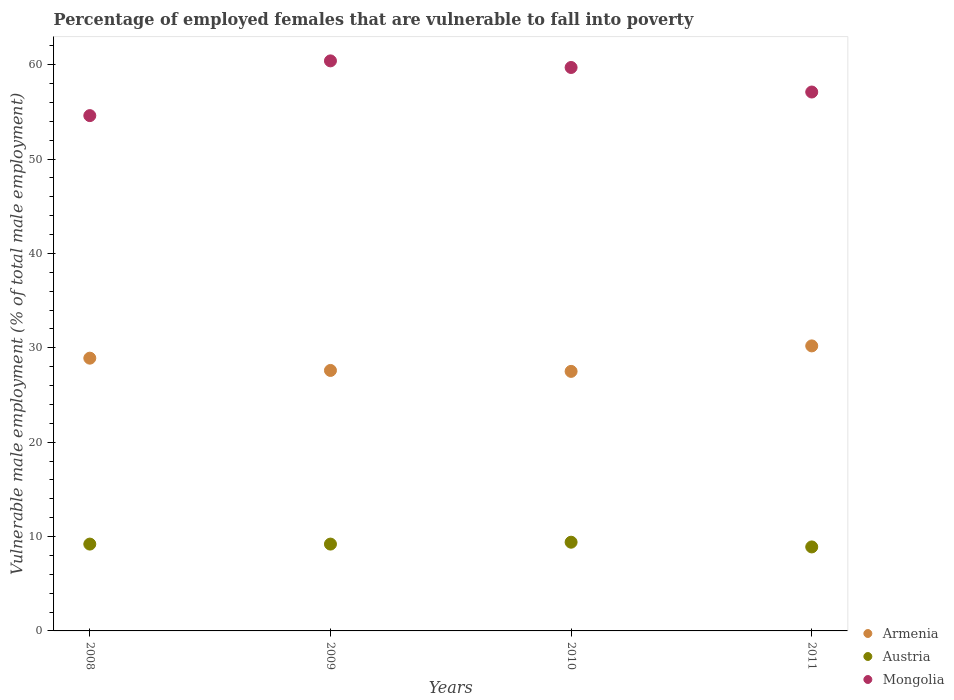Is the number of dotlines equal to the number of legend labels?
Provide a short and direct response. Yes. What is the percentage of employed females who are vulnerable to fall into poverty in Austria in 2011?
Make the answer very short. 8.9. Across all years, what is the maximum percentage of employed females who are vulnerable to fall into poverty in Mongolia?
Make the answer very short. 60.4. In which year was the percentage of employed females who are vulnerable to fall into poverty in Mongolia maximum?
Your response must be concise. 2009. What is the total percentage of employed females who are vulnerable to fall into poverty in Austria in the graph?
Offer a terse response. 36.7. What is the difference between the percentage of employed females who are vulnerable to fall into poverty in Armenia in 2009 and that in 2010?
Keep it short and to the point. 0.1. What is the difference between the percentage of employed females who are vulnerable to fall into poverty in Austria in 2011 and the percentage of employed females who are vulnerable to fall into poverty in Armenia in 2008?
Provide a short and direct response. -20. What is the average percentage of employed females who are vulnerable to fall into poverty in Armenia per year?
Your response must be concise. 28.55. In the year 2008, what is the difference between the percentage of employed females who are vulnerable to fall into poverty in Austria and percentage of employed females who are vulnerable to fall into poverty in Mongolia?
Provide a short and direct response. -45.4. In how many years, is the percentage of employed females who are vulnerable to fall into poverty in Austria greater than 44 %?
Make the answer very short. 0. What is the ratio of the percentage of employed females who are vulnerable to fall into poverty in Armenia in 2008 to that in 2011?
Ensure brevity in your answer.  0.96. Is the percentage of employed females who are vulnerable to fall into poverty in Mongolia in 2008 less than that in 2011?
Offer a very short reply. Yes. Is the difference between the percentage of employed females who are vulnerable to fall into poverty in Austria in 2009 and 2011 greater than the difference between the percentage of employed females who are vulnerable to fall into poverty in Mongolia in 2009 and 2011?
Give a very brief answer. No. What is the difference between the highest and the second highest percentage of employed females who are vulnerable to fall into poverty in Mongolia?
Your response must be concise. 0.7. In how many years, is the percentage of employed females who are vulnerable to fall into poverty in Armenia greater than the average percentage of employed females who are vulnerable to fall into poverty in Armenia taken over all years?
Make the answer very short. 2. Is the percentage of employed females who are vulnerable to fall into poverty in Mongolia strictly greater than the percentage of employed females who are vulnerable to fall into poverty in Austria over the years?
Provide a succinct answer. Yes. Does the graph contain grids?
Offer a terse response. No. How many legend labels are there?
Make the answer very short. 3. What is the title of the graph?
Keep it short and to the point. Percentage of employed females that are vulnerable to fall into poverty. What is the label or title of the X-axis?
Offer a terse response. Years. What is the label or title of the Y-axis?
Your response must be concise. Vulnerable male employment (% of total male employment). What is the Vulnerable male employment (% of total male employment) in Armenia in 2008?
Offer a very short reply. 28.9. What is the Vulnerable male employment (% of total male employment) of Austria in 2008?
Keep it short and to the point. 9.2. What is the Vulnerable male employment (% of total male employment) of Mongolia in 2008?
Offer a terse response. 54.6. What is the Vulnerable male employment (% of total male employment) in Armenia in 2009?
Offer a very short reply. 27.6. What is the Vulnerable male employment (% of total male employment) in Austria in 2009?
Your answer should be very brief. 9.2. What is the Vulnerable male employment (% of total male employment) in Mongolia in 2009?
Provide a short and direct response. 60.4. What is the Vulnerable male employment (% of total male employment) in Austria in 2010?
Your response must be concise. 9.4. What is the Vulnerable male employment (% of total male employment) of Mongolia in 2010?
Your answer should be very brief. 59.7. What is the Vulnerable male employment (% of total male employment) of Armenia in 2011?
Your answer should be very brief. 30.2. What is the Vulnerable male employment (% of total male employment) in Austria in 2011?
Offer a very short reply. 8.9. What is the Vulnerable male employment (% of total male employment) of Mongolia in 2011?
Provide a short and direct response. 57.1. Across all years, what is the maximum Vulnerable male employment (% of total male employment) in Armenia?
Provide a succinct answer. 30.2. Across all years, what is the maximum Vulnerable male employment (% of total male employment) of Austria?
Offer a very short reply. 9.4. Across all years, what is the maximum Vulnerable male employment (% of total male employment) of Mongolia?
Provide a short and direct response. 60.4. Across all years, what is the minimum Vulnerable male employment (% of total male employment) of Austria?
Provide a succinct answer. 8.9. Across all years, what is the minimum Vulnerable male employment (% of total male employment) in Mongolia?
Your answer should be very brief. 54.6. What is the total Vulnerable male employment (% of total male employment) of Armenia in the graph?
Your answer should be compact. 114.2. What is the total Vulnerable male employment (% of total male employment) of Austria in the graph?
Offer a very short reply. 36.7. What is the total Vulnerable male employment (% of total male employment) of Mongolia in the graph?
Give a very brief answer. 231.8. What is the difference between the Vulnerable male employment (% of total male employment) of Armenia in 2008 and that in 2009?
Keep it short and to the point. 1.3. What is the difference between the Vulnerable male employment (% of total male employment) of Armenia in 2008 and that in 2010?
Offer a very short reply. 1.4. What is the difference between the Vulnerable male employment (% of total male employment) in Mongolia in 2008 and that in 2010?
Give a very brief answer. -5.1. What is the difference between the Vulnerable male employment (% of total male employment) of Armenia in 2009 and that in 2010?
Make the answer very short. 0.1. What is the difference between the Vulnerable male employment (% of total male employment) in Armenia in 2009 and that in 2011?
Your answer should be very brief. -2.6. What is the difference between the Vulnerable male employment (% of total male employment) of Mongolia in 2009 and that in 2011?
Make the answer very short. 3.3. What is the difference between the Vulnerable male employment (% of total male employment) of Armenia in 2010 and that in 2011?
Provide a succinct answer. -2.7. What is the difference between the Vulnerable male employment (% of total male employment) of Mongolia in 2010 and that in 2011?
Provide a succinct answer. 2.6. What is the difference between the Vulnerable male employment (% of total male employment) in Armenia in 2008 and the Vulnerable male employment (% of total male employment) in Austria in 2009?
Make the answer very short. 19.7. What is the difference between the Vulnerable male employment (% of total male employment) in Armenia in 2008 and the Vulnerable male employment (% of total male employment) in Mongolia in 2009?
Your answer should be compact. -31.5. What is the difference between the Vulnerable male employment (% of total male employment) of Austria in 2008 and the Vulnerable male employment (% of total male employment) of Mongolia in 2009?
Your answer should be very brief. -51.2. What is the difference between the Vulnerable male employment (% of total male employment) in Armenia in 2008 and the Vulnerable male employment (% of total male employment) in Mongolia in 2010?
Ensure brevity in your answer.  -30.8. What is the difference between the Vulnerable male employment (% of total male employment) in Austria in 2008 and the Vulnerable male employment (% of total male employment) in Mongolia in 2010?
Keep it short and to the point. -50.5. What is the difference between the Vulnerable male employment (% of total male employment) of Armenia in 2008 and the Vulnerable male employment (% of total male employment) of Mongolia in 2011?
Offer a very short reply. -28.2. What is the difference between the Vulnerable male employment (% of total male employment) of Austria in 2008 and the Vulnerable male employment (% of total male employment) of Mongolia in 2011?
Offer a terse response. -47.9. What is the difference between the Vulnerable male employment (% of total male employment) of Armenia in 2009 and the Vulnerable male employment (% of total male employment) of Austria in 2010?
Your answer should be compact. 18.2. What is the difference between the Vulnerable male employment (% of total male employment) in Armenia in 2009 and the Vulnerable male employment (% of total male employment) in Mongolia in 2010?
Offer a terse response. -32.1. What is the difference between the Vulnerable male employment (% of total male employment) in Austria in 2009 and the Vulnerable male employment (% of total male employment) in Mongolia in 2010?
Offer a very short reply. -50.5. What is the difference between the Vulnerable male employment (% of total male employment) in Armenia in 2009 and the Vulnerable male employment (% of total male employment) in Mongolia in 2011?
Ensure brevity in your answer.  -29.5. What is the difference between the Vulnerable male employment (% of total male employment) in Austria in 2009 and the Vulnerable male employment (% of total male employment) in Mongolia in 2011?
Your response must be concise. -47.9. What is the difference between the Vulnerable male employment (% of total male employment) of Armenia in 2010 and the Vulnerable male employment (% of total male employment) of Austria in 2011?
Keep it short and to the point. 18.6. What is the difference between the Vulnerable male employment (% of total male employment) in Armenia in 2010 and the Vulnerable male employment (% of total male employment) in Mongolia in 2011?
Give a very brief answer. -29.6. What is the difference between the Vulnerable male employment (% of total male employment) of Austria in 2010 and the Vulnerable male employment (% of total male employment) of Mongolia in 2011?
Offer a terse response. -47.7. What is the average Vulnerable male employment (% of total male employment) in Armenia per year?
Provide a succinct answer. 28.55. What is the average Vulnerable male employment (% of total male employment) in Austria per year?
Provide a short and direct response. 9.18. What is the average Vulnerable male employment (% of total male employment) of Mongolia per year?
Your answer should be very brief. 57.95. In the year 2008, what is the difference between the Vulnerable male employment (% of total male employment) of Armenia and Vulnerable male employment (% of total male employment) of Mongolia?
Give a very brief answer. -25.7. In the year 2008, what is the difference between the Vulnerable male employment (% of total male employment) in Austria and Vulnerable male employment (% of total male employment) in Mongolia?
Give a very brief answer. -45.4. In the year 2009, what is the difference between the Vulnerable male employment (% of total male employment) of Armenia and Vulnerable male employment (% of total male employment) of Mongolia?
Offer a terse response. -32.8. In the year 2009, what is the difference between the Vulnerable male employment (% of total male employment) in Austria and Vulnerable male employment (% of total male employment) in Mongolia?
Ensure brevity in your answer.  -51.2. In the year 2010, what is the difference between the Vulnerable male employment (% of total male employment) in Armenia and Vulnerable male employment (% of total male employment) in Mongolia?
Provide a succinct answer. -32.2. In the year 2010, what is the difference between the Vulnerable male employment (% of total male employment) in Austria and Vulnerable male employment (% of total male employment) in Mongolia?
Keep it short and to the point. -50.3. In the year 2011, what is the difference between the Vulnerable male employment (% of total male employment) of Armenia and Vulnerable male employment (% of total male employment) of Austria?
Offer a very short reply. 21.3. In the year 2011, what is the difference between the Vulnerable male employment (% of total male employment) in Armenia and Vulnerable male employment (% of total male employment) in Mongolia?
Ensure brevity in your answer.  -26.9. In the year 2011, what is the difference between the Vulnerable male employment (% of total male employment) in Austria and Vulnerable male employment (% of total male employment) in Mongolia?
Give a very brief answer. -48.2. What is the ratio of the Vulnerable male employment (% of total male employment) of Armenia in 2008 to that in 2009?
Your answer should be very brief. 1.05. What is the ratio of the Vulnerable male employment (% of total male employment) of Mongolia in 2008 to that in 2009?
Your response must be concise. 0.9. What is the ratio of the Vulnerable male employment (% of total male employment) in Armenia in 2008 to that in 2010?
Keep it short and to the point. 1.05. What is the ratio of the Vulnerable male employment (% of total male employment) of Austria in 2008 to that in 2010?
Offer a terse response. 0.98. What is the ratio of the Vulnerable male employment (% of total male employment) of Mongolia in 2008 to that in 2010?
Offer a very short reply. 0.91. What is the ratio of the Vulnerable male employment (% of total male employment) of Armenia in 2008 to that in 2011?
Keep it short and to the point. 0.96. What is the ratio of the Vulnerable male employment (% of total male employment) of Austria in 2008 to that in 2011?
Keep it short and to the point. 1.03. What is the ratio of the Vulnerable male employment (% of total male employment) of Mongolia in 2008 to that in 2011?
Keep it short and to the point. 0.96. What is the ratio of the Vulnerable male employment (% of total male employment) in Armenia in 2009 to that in 2010?
Provide a succinct answer. 1. What is the ratio of the Vulnerable male employment (% of total male employment) in Austria in 2009 to that in 2010?
Ensure brevity in your answer.  0.98. What is the ratio of the Vulnerable male employment (% of total male employment) of Mongolia in 2009 to that in 2010?
Provide a short and direct response. 1.01. What is the ratio of the Vulnerable male employment (% of total male employment) of Armenia in 2009 to that in 2011?
Ensure brevity in your answer.  0.91. What is the ratio of the Vulnerable male employment (% of total male employment) of Austria in 2009 to that in 2011?
Your response must be concise. 1.03. What is the ratio of the Vulnerable male employment (% of total male employment) of Mongolia in 2009 to that in 2011?
Provide a succinct answer. 1.06. What is the ratio of the Vulnerable male employment (% of total male employment) in Armenia in 2010 to that in 2011?
Provide a short and direct response. 0.91. What is the ratio of the Vulnerable male employment (% of total male employment) in Austria in 2010 to that in 2011?
Your response must be concise. 1.06. What is the ratio of the Vulnerable male employment (% of total male employment) of Mongolia in 2010 to that in 2011?
Keep it short and to the point. 1.05. What is the difference between the highest and the second highest Vulnerable male employment (% of total male employment) of Austria?
Keep it short and to the point. 0.2. What is the difference between the highest and the lowest Vulnerable male employment (% of total male employment) of Austria?
Keep it short and to the point. 0.5. What is the difference between the highest and the lowest Vulnerable male employment (% of total male employment) of Mongolia?
Offer a very short reply. 5.8. 